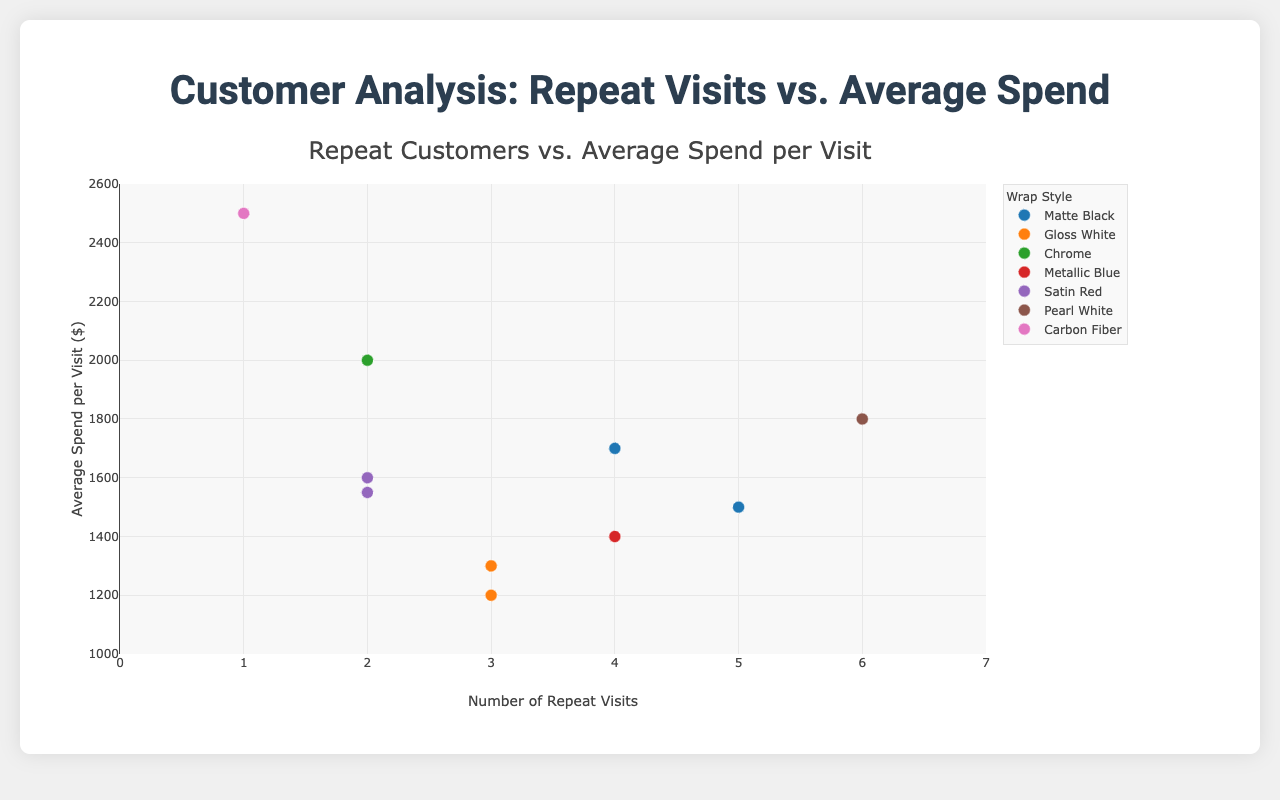What is the title of the plot? The title is usually located at the top of the plot and gives an overview of what the plot represents.
Answer: Customer Analysis: Repeat Visits vs. Average Spend What is the range of the x-axis? The x-axis represents the Number of Repeat Visits. The range is indicated by the minimum and maximum values on this axis.
Answer: 0 to 7 Which wrap style corresponds to the highest average spend per visit? By observing the y-axis values and the color/symbol legend, we can identify the wrap style associated with the highest y-value.
Answer: Carbon Fiber How many data points represent the Average Spend per Visit for Age 18-25 demographics? The demographics "Age 18-25" can be identified by their respective data points in different colors. Count the data points associated with "Age 18-25".
Answer: 2 What is the preferred wrap style among customers aged 36-45, Male? Look for data points associated with the demographic "Age 36-45, Male" and observe the corresponding wrap styles in the legend.
Answer: Pearl White Which demographic group shows the highest number of repeat customers? Identify the demographic group with the highest x-axis value by checking the data points corresponding to "Repeat Customers".
Answer: Age 36-45, Male What is the average spend per visit for female customers aged 26-35? Find the data point marked as "Age 26-35, Female" and look at the y-axis value corresponding to this point.
Answer: 1550 Compare the average spend per visit between the "Matte Black" and "Satin Red" wrap styles. Which one is higher? Observe the data points for "Matte Black" and "Satin Red" styles and compare their respective y-axis values.
Answer: "Satin Red" has a higher average spend per visit What is the total number of repeat visits for customers using "Matte Black" wrap style? Identify all data points associated with "Matte Black" wrap style and sum their x-axis values.
Answer: 9 How does the average spend per visit vary among customers aged 46-55? Observe the y-axis values for data points under the demographic group "Age 46-55" and compare the differences.
Answer: Average spend varies between 1300 and 1700 